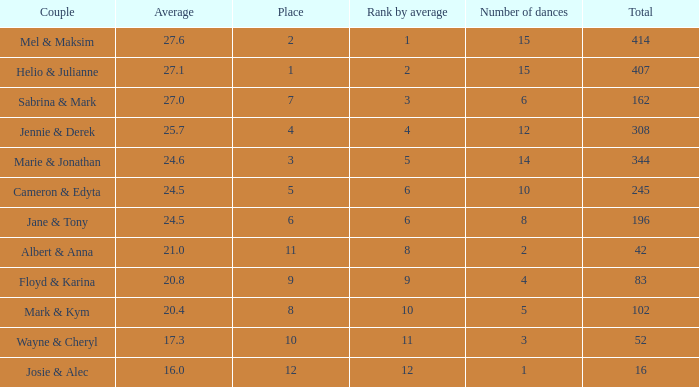What is the average when the rank by average is more than 12? None. 